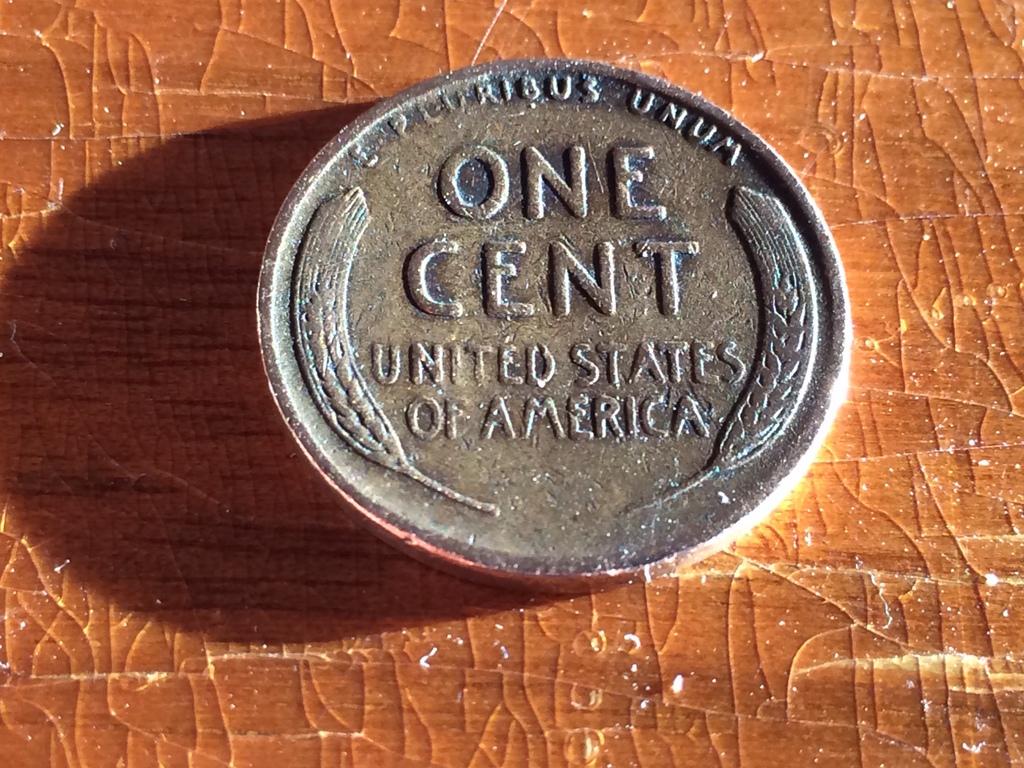How much is this coin worth?
Ensure brevity in your answer.  One cent. What country made the coin?
Provide a succinct answer. United states of america. 